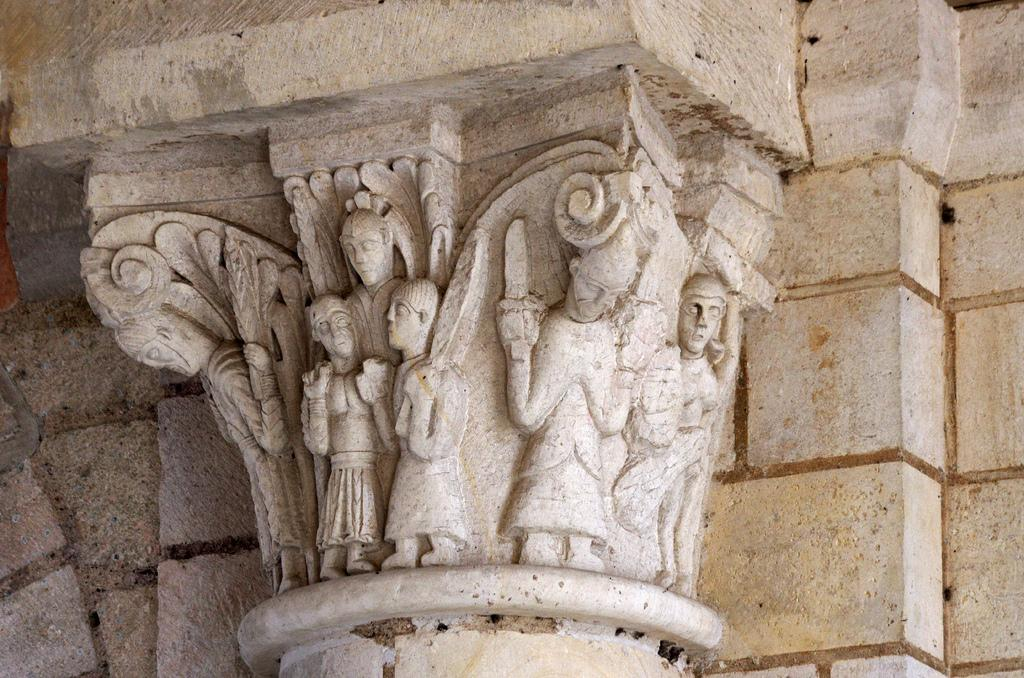What is depicted on the wall in the image? There are sculptures on a wall in the image. Can you describe the lighting conditions in the image? The image was likely taken during the day, as there is sufficient natural light. What type of zipper can be seen on the sculptures in the image? There are no zippers present on the sculptures in the image. How many men are visible in the image? There is no information about men in the image, as the focus is on the sculptures on the wall. 